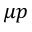<formula> <loc_0><loc_0><loc_500><loc_500>\mu p</formula> 